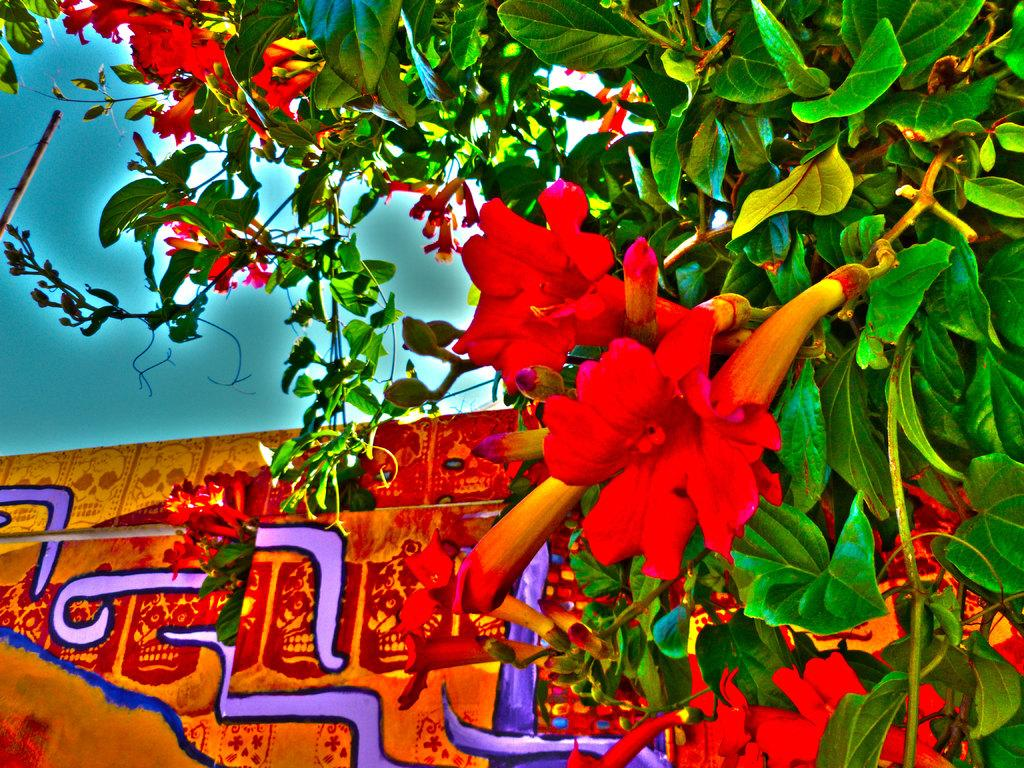What type of plant is present in the image? There is a tree with flowers in the image. What else can be seen in the image besides the tree? There is an object in the image. What can be seen in the background of the image? The sky is visible in the background of the image. Where is the parcel being delivered in the image? There is no parcel present in the image, so it cannot be determined where it would be delivered. 